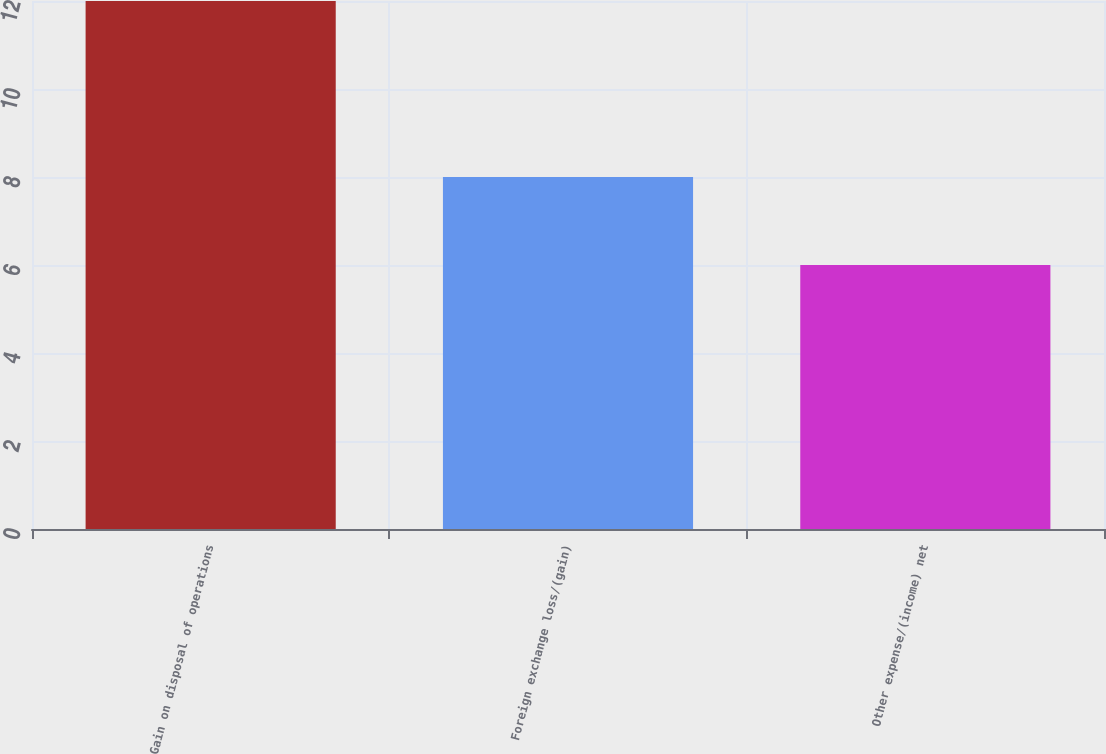<chart> <loc_0><loc_0><loc_500><loc_500><bar_chart><fcel>Gain on disposal of operations<fcel>Foreign exchange loss/(gain)<fcel>Other expense/(income) net<nl><fcel>12<fcel>8<fcel>6<nl></chart> 